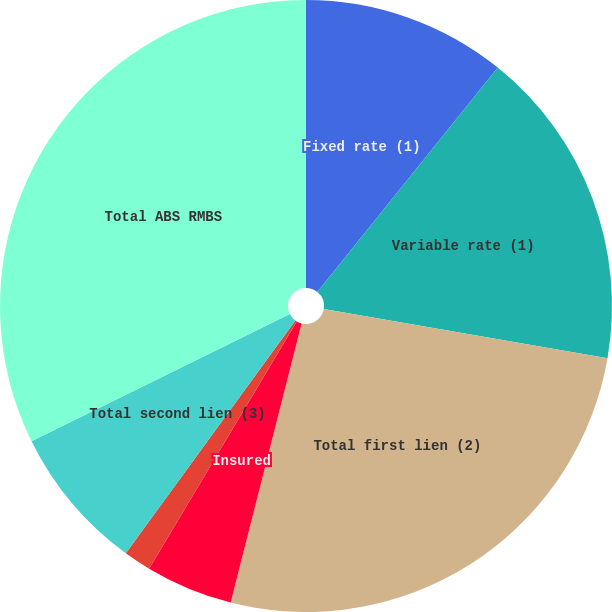Convert chart to OTSL. <chart><loc_0><loc_0><loc_500><loc_500><pie_chart><fcel>Fixed rate (1)<fcel>Variable rate (1)<fcel>Total first lien (2)<fcel>Insured<fcel>Other<fcel>Total second lien (3)<fcel>Total ABS RMBS<nl><fcel>10.78%<fcel>16.95%<fcel>26.23%<fcel>4.61%<fcel>1.45%<fcel>7.69%<fcel>32.29%<nl></chart> 